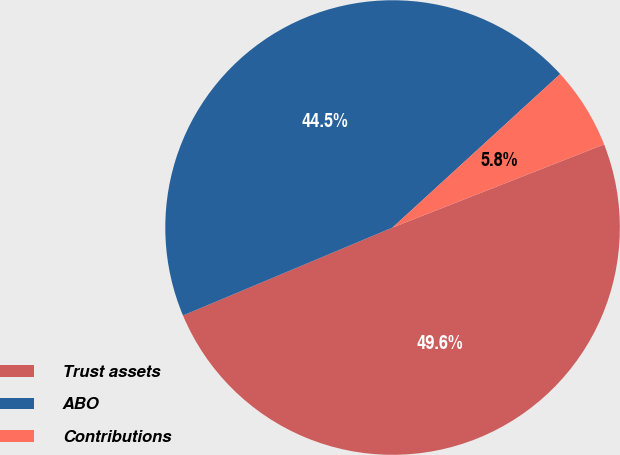Convert chart. <chart><loc_0><loc_0><loc_500><loc_500><pie_chart><fcel>Trust assets<fcel>ABO<fcel>Contributions<nl><fcel>49.64%<fcel>44.53%<fcel>5.84%<nl></chart> 